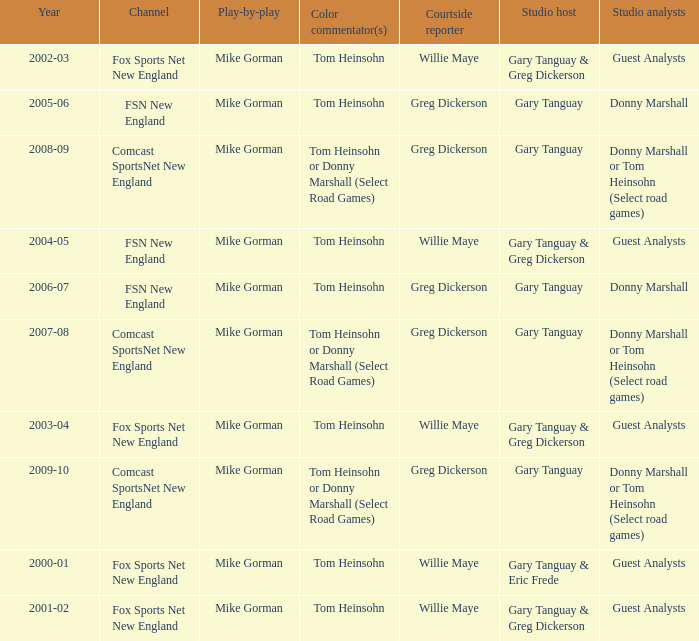Could you help me parse every detail presented in this table? {'header': ['Year', 'Channel', 'Play-by-play', 'Color commentator(s)', 'Courtside reporter', 'Studio host', 'Studio analysts'], 'rows': [['2002-03', 'Fox Sports Net New England', 'Mike Gorman', 'Tom Heinsohn', 'Willie Maye', 'Gary Tanguay & Greg Dickerson', 'Guest Analysts'], ['2005-06', 'FSN New England', 'Mike Gorman', 'Tom Heinsohn', 'Greg Dickerson', 'Gary Tanguay', 'Donny Marshall'], ['2008-09', 'Comcast SportsNet New England', 'Mike Gorman', 'Tom Heinsohn or Donny Marshall (Select Road Games)', 'Greg Dickerson', 'Gary Tanguay', 'Donny Marshall or Tom Heinsohn (Select road games)'], ['2004-05', 'FSN New England', 'Mike Gorman', 'Tom Heinsohn', 'Willie Maye', 'Gary Tanguay & Greg Dickerson', 'Guest Analysts'], ['2006-07', 'FSN New England', 'Mike Gorman', 'Tom Heinsohn', 'Greg Dickerson', 'Gary Tanguay', 'Donny Marshall'], ['2007-08', 'Comcast SportsNet New England', 'Mike Gorman', 'Tom Heinsohn or Donny Marshall (Select Road Games)', 'Greg Dickerson', 'Gary Tanguay', 'Donny Marshall or Tom Heinsohn (Select road games)'], ['2003-04', 'Fox Sports Net New England', 'Mike Gorman', 'Tom Heinsohn', 'Willie Maye', 'Gary Tanguay & Greg Dickerson', 'Guest Analysts'], ['2009-10', 'Comcast SportsNet New England', 'Mike Gorman', 'Tom Heinsohn or Donny Marshall (Select Road Games)', 'Greg Dickerson', 'Gary Tanguay', 'Donny Marshall or Tom Heinsohn (Select road games)'], ['2000-01', 'Fox Sports Net New England', 'Mike Gorman', 'Tom Heinsohn', 'Willie Maye', 'Gary Tanguay & Eric Frede', 'Guest Analysts'], ['2001-02', 'Fox Sports Net New England', 'Mike Gorman', 'Tom Heinsohn', 'Willie Maye', 'Gary Tanguay & Greg Dickerson', 'Guest Analysts']]} WHich Play-by-play has a Studio host of gary tanguay, and a Studio analysts of donny marshall? Mike Gorman, Mike Gorman. 